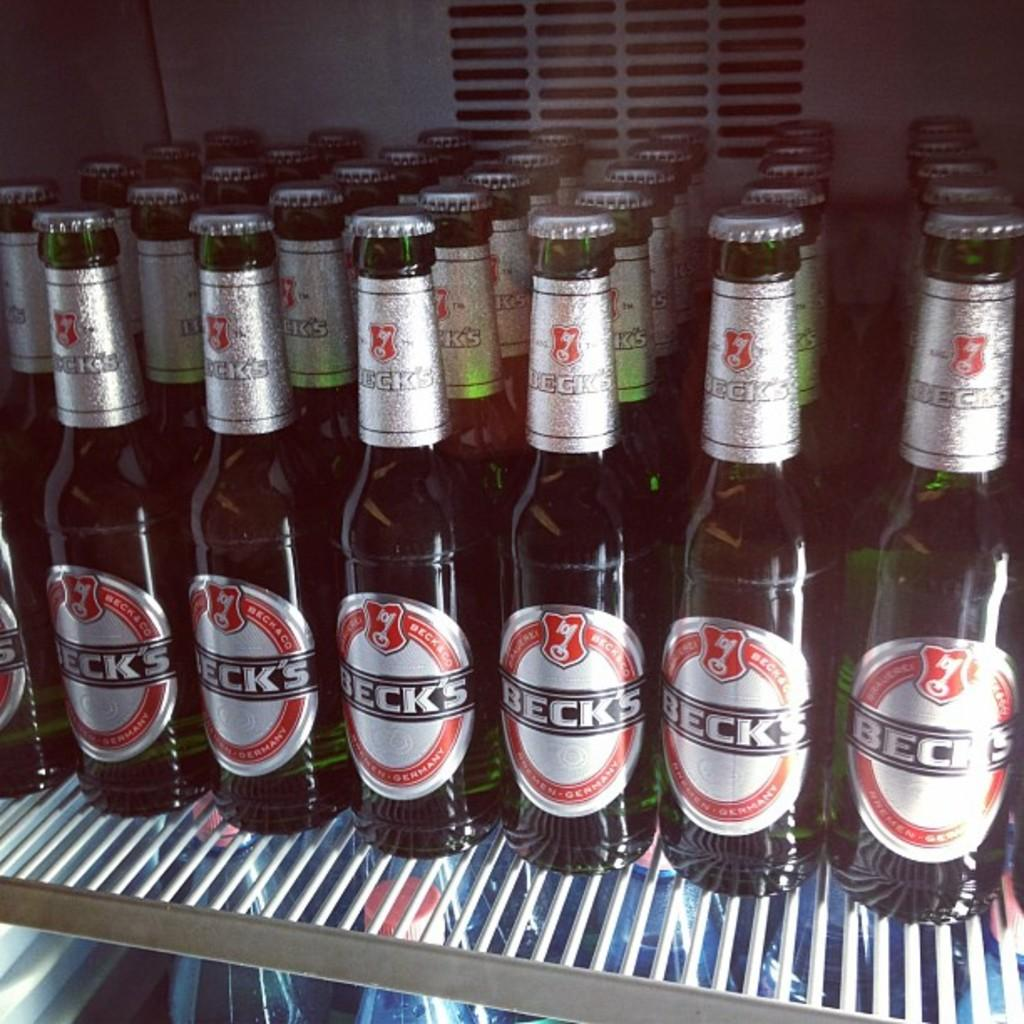<image>
Share a concise interpretation of the image provided. Several bottles of Beck's beer sit on a white wire shelf. 